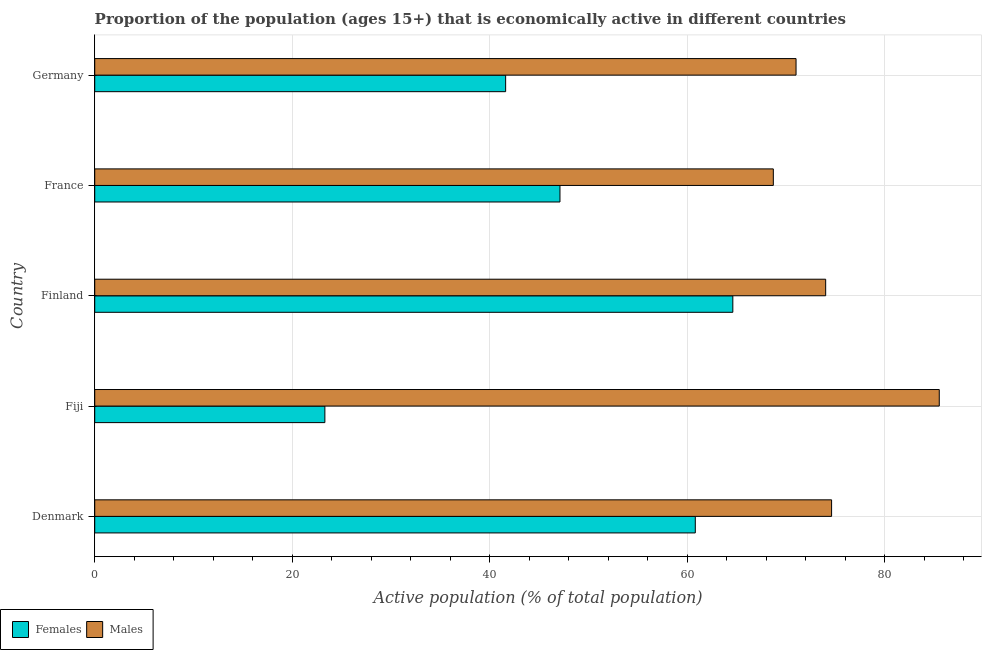Are the number of bars on each tick of the Y-axis equal?
Your response must be concise. Yes. How many bars are there on the 4th tick from the top?
Make the answer very short. 2. In how many cases, is the number of bars for a given country not equal to the number of legend labels?
Provide a succinct answer. 0. What is the percentage of economically active male population in Germany?
Ensure brevity in your answer.  71. Across all countries, what is the maximum percentage of economically active female population?
Offer a terse response. 64.6. Across all countries, what is the minimum percentage of economically active male population?
Ensure brevity in your answer.  68.7. In which country was the percentage of economically active male population maximum?
Offer a very short reply. Fiji. In which country was the percentage of economically active male population minimum?
Offer a terse response. France. What is the total percentage of economically active female population in the graph?
Keep it short and to the point. 237.4. What is the difference between the percentage of economically active male population in Fiji and that in Germany?
Your response must be concise. 14.5. What is the difference between the percentage of economically active male population in Fiji and the percentage of economically active female population in Finland?
Provide a short and direct response. 20.9. What is the average percentage of economically active female population per country?
Give a very brief answer. 47.48. What is the difference between the percentage of economically active male population and percentage of economically active female population in Germany?
Keep it short and to the point. 29.4. What is the ratio of the percentage of economically active female population in Fiji to that in Finland?
Make the answer very short. 0.36. Is the percentage of economically active female population in Fiji less than that in Finland?
Ensure brevity in your answer.  Yes. Is the difference between the percentage of economically active female population in France and Germany greater than the difference between the percentage of economically active male population in France and Germany?
Make the answer very short. Yes. What is the difference between the highest and the lowest percentage of economically active female population?
Your answer should be very brief. 41.3. In how many countries, is the percentage of economically active male population greater than the average percentage of economically active male population taken over all countries?
Ensure brevity in your answer.  1. What does the 2nd bar from the top in Fiji represents?
Your response must be concise. Females. What does the 2nd bar from the bottom in Fiji represents?
Offer a very short reply. Males. Are all the bars in the graph horizontal?
Provide a short and direct response. Yes. What is the difference between two consecutive major ticks on the X-axis?
Offer a terse response. 20. Does the graph contain any zero values?
Provide a succinct answer. No. Does the graph contain grids?
Ensure brevity in your answer.  Yes. Where does the legend appear in the graph?
Make the answer very short. Bottom left. How many legend labels are there?
Ensure brevity in your answer.  2. What is the title of the graph?
Your answer should be very brief. Proportion of the population (ages 15+) that is economically active in different countries. Does "Net savings(excluding particulate emission damage)" appear as one of the legend labels in the graph?
Make the answer very short. No. What is the label or title of the X-axis?
Make the answer very short. Active population (% of total population). What is the label or title of the Y-axis?
Offer a very short reply. Country. What is the Active population (% of total population) of Females in Denmark?
Your answer should be compact. 60.8. What is the Active population (% of total population) in Males in Denmark?
Ensure brevity in your answer.  74.6. What is the Active population (% of total population) in Females in Fiji?
Provide a short and direct response. 23.3. What is the Active population (% of total population) of Males in Fiji?
Ensure brevity in your answer.  85.5. What is the Active population (% of total population) in Females in Finland?
Provide a succinct answer. 64.6. What is the Active population (% of total population) of Females in France?
Give a very brief answer. 47.1. What is the Active population (% of total population) of Males in France?
Give a very brief answer. 68.7. What is the Active population (% of total population) in Females in Germany?
Make the answer very short. 41.6. What is the Active population (% of total population) of Males in Germany?
Your answer should be very brief. 71. Across all countries, what is the maximum Active population (% of total population) in Females?
Make the answer very short. 64.6. Across all countries, what is the maximum Active population (% of total population) of Males?
Offer a terse response. 85.5. Across all countries, what is the minimum Active population (% of total population) of Females?
Provide a succinct answer. 23.3. Across all countries, what is the minimum Active population (% of total population) in Males?
Ensure brevity in your answer.  68.7. What is the total Active population (% of total population) of Females in the graph?
Provide a succinct answer. 237.4. What is the total Active population (% of total population) in Males in the graph?
Provide a short and direct response. 373.8. What is the difference between the Active population (% of total population) of Females in Denmark and that in Fiji?
Ensure brevity in your answer.  37.5. What is the difference between the Active population (% of total population) in Females in Denmark and that in Finland?
Ensure brevity in your answer.  -3.8. What is the difference between the Active population (% of total population) in Males in Denmark and that in Finland?
Ensure brevity in your answer.  0.6. What is the difference between the Active population (% of total population) in Females in Denmark and that in Germany?
Keep it short and to the point. 19.2. What is the difference between the Active population (% of total population) of Males in Denmark and that in Germany?
Your answer should be very brief. 3.6. What is the difference between the Active population (% of total population) of Females in Fiji and that in Finland?
Make the answer very short. -41.3. What is the difference between the Active population (% of total population) of Females in Fiji and that in France?
Offer a terse response. -23.8. What is the difference between the Active population (% of total population) in Males in Fiji and that in France?
Ensure brevity in your answer.  16.8. What is the difference between the Active population (% of total population) in Females in Fiji and that in Germany?
Provide a succinct answer. -18.3. What is the difference between the Active population (% of total population) in Males in Fiji and that in Germany?
Your answer should be compact. 14.5. What is the difference between the Active population (% of total population) in Females in Finland and that in France?
Offer a terse response. 17.5. What is the difference between the Active population (% of total population) of Males in France and that in Germany?
Your response must be concise. -2.3. What is the difference between the Active population (% of total population) of Females in Denmark and the Active population (% of total population) of Males in Fiji?
Your answer should be compact. -24.7. What is the difference between the Active population (% of total population) in Females in Denmark and the Active population (% of total population) in Males in France?
Make the answer very short. -7.9. What is the difference between the Active population (% of total population) in Females in Denmark and the Active population (% of total population) in Males in Germany?
Offer a very short reply. -10.2. What is the difference between the Active population (% of total population) of Females in Fiji and the Active population (% of total population) of Males in Finland?
Your answer should be very brief. -50.7. What is the difference between the Active population (% of total population) of Females in Fiji and the Active population (% of total population) of Males in France?
Your response must be concise. -45.4. What is the difference between the Active population (% of total population) of Females in Fiji and the Active population (% of total population) of Males in Germany?
Provide a succinct answer. -47.7. What is the difference between the Active population (% of total population) of Females in Finland and the Active population (% of total population) of Males in France?
Provide a short and direct response. -4.1. What is the difference between the Active population (% of total population) of Females in France and the Active population (% of total population) of Males in Germany?
Make the answer very short. -23.9. What is the average Active population (% of total population) of Females per country?
Keep it short and to the point. 47.48. What is the average Active population (% of total population) in Males per country?
Offer a terse response. 74.76. What is the difference between the Active population (% of total population) of Females and Active population (% of total population) of Males in Denmark?
Offer a very short reply. -13.8. What is the difference between the Active population (% of total population) of Females and Active population (% of total population) of Males in Fiji?
Your answer should be very brief. -62.2. What is the difference between the Active population (% of total population) in Females and Active population (% of total population) in Males in Finland?
Your answer should be compact. -9.4. What is the difference between the Active population (% of total population) in Females and Active population (% of total population) in Males in France?
Make the answer very short. -21.6. What is the difference between the Active population (% of total population) of Females and Active population (% of total population) of Males in Germany?
Keep it short and to the point. -29.4. What is the ratio of the Active population (% of total population) in Females in Denmark to that in Fiji?
Give a very brief answer. 2.61. What is the ratio of the Active population (% of total population) in Males in Denmark to that in Fiji?
Make the answer very short. 0.87. What is the ratio of the Active population (% of total population) in Females in Denmark to that in Finland?
Offer a terse response. 0.94. What is the ratio of the Active population (% of total population) in Females in Denmark to that in France?
Make the answer very short. 1.29. What is the ratio of the Active population (% of total population) of Males in Denmark to that in France?
Make the answer very short. 1.09. What is the ratio of the Active population (% of total population) of Females in Denmark to that in Germany?
Make the answer very short. 1.46. What is the ratio of the Active population (% of total population) of Males in Denmark to that in Germany?
Your answer should be compact. 1.05. What is the ratio of the Active population (% of total population) of Females in Fiji to that in Finland?
Ensure brevity in your answer.  0.36. What is the ratio of the Active population (% of total population) in Males in Fiji to that in Finland?
Ensure brevity in your answer.  1.16. What is the ratio of the Active population (% of total population) of Females in Fiji to that in France?
Provide a succinct answer. 0.49. What is the ratio of the Active population (% of total population) of Males in Fiji to that in France?
Provide a succinct answer. 1.24. What is the ratio of the Active population (% of total population) in Females in Fiji to that in Germany?
Make the answer very short. 0.56. What is the ratio of the Active population (% of total population) in Males in Fiji to that in Germany?
Your response must be concise. 1.2. What is the ratio of the Active population (% of total population) of Females in Finland to that in France?
Give a very brief answer. 1.37. What is the ratio of the Active population (% of total population) of Males in Finland to that in France?
Make the answer very short. 1.08. What is the ratio of the Active population (% of total population) of Females in Finland to that in Germany?
Give a very brief answer. 1.55. What is the ratio of the Active population (% of total population) in Males in Finland to that in Germany?
Provide a succinct answer. 1.04. What is the ratio of the Active population (% of total population) in Females in France to that in Germany?
Provide a succinct answer. 1.13. What is the ratio of the Active population (% of total population) in Males in France to that in Germany?
Give a very brief answer. 0.97. What is the difference between the highest and the second highest Active population (% of total population) in Females?
Offer a very short reply. 3.8. What is the difference between the highest and the second highest Active population (% of total population) of Males?
Offer a very short reply. 10.9. What is the difference between the highest and the lowest Active population (% of total population) in Females?
Give a very brief answer. 41.3. What is the difference between the highest and the lowest Active population (% of total population) of Males?
Provide a succinct answer. 16.8. 